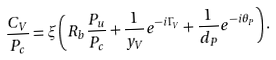Convert formula to latex. <formula><loc_0><loc_0><loc_500><loc_500>\frac { C _ { V } } { P _ { c } } = \xi \left ( R _ { b } \frac { P _ { u } } { P _ { c } } + \frac { 1 } { y _ { V } } e ^ { - i \Gamma _ { V } } + \frac { 1 } { d _ { P } } e ^ { - i \theta _ { P } } \right ) .</formula> 